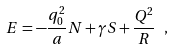Convert formula to latex. <formula><loc_0><loc_0><loc_500><loc_500>E = - \frac { q _ { 0 } ^ { 2 } } { a } N + \gamma S + \frac { Q ^ { 2 } } { R } \ ,</formula> 